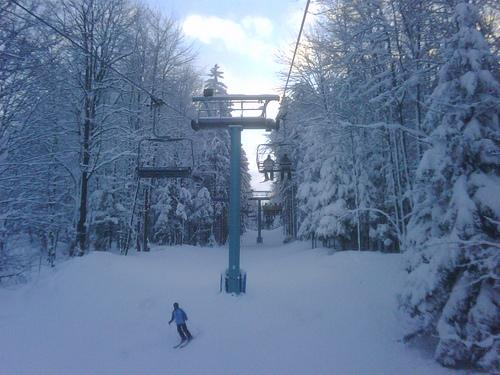Where are the people on the wire going? Please explain your reasoning. summit. Based on the setting and the visible equipment, the people are skiing and the visible lift would be there to bring them up the mountain. 